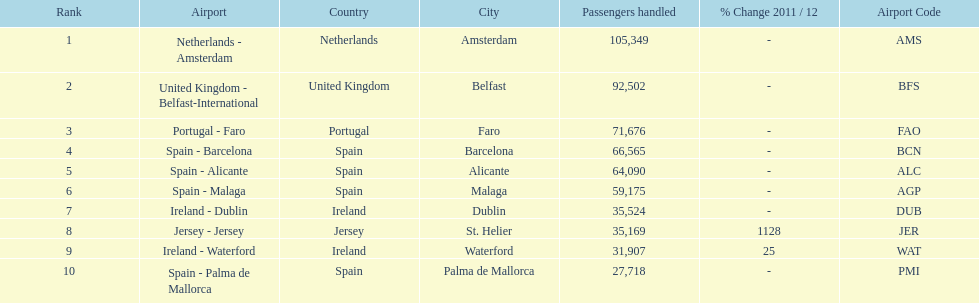What is the name of the only airport in portugal that is among the 10 busiest routes to and from london southend airport in 2012? Portugal - Faro. 